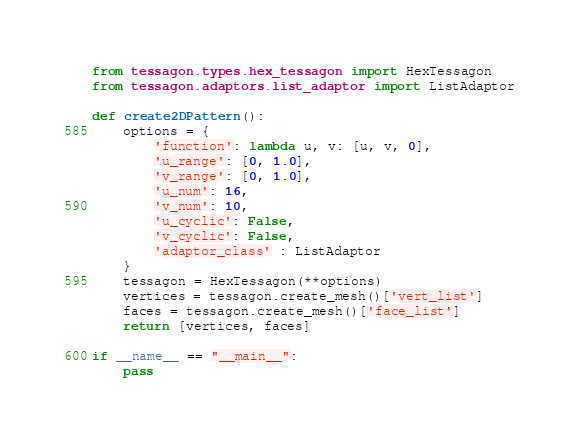Convert code to text. <code><loc_0><loc_0><loc_500><loc_500><_Python_>from tessagon.types.hex_tessagon import HexTessagon
from tessagon.adaptors.list_adaptor import ListAdaptor

def create2DPattern():
	options = {
    	'function': lambda u, v: [u, v, 0],
    	'u_range': [0, 1.0],
    	'v_range': [0, 1.0],
    	'u_num': 16,
    	'v_num': 10,
    	'u_cyclic': False,
    	'v_cyclic': False,
    	'adaptor_class' : ListAdaptor
  	}
	tessagon = HexTessagon(**options)
	vertices = tessagon.create_mesh()['vert_list']
	faces = tessagon.create_mesh()['face_list']
	return [vertices, faces]

if __name__ == "__main__":
    pass</code> 